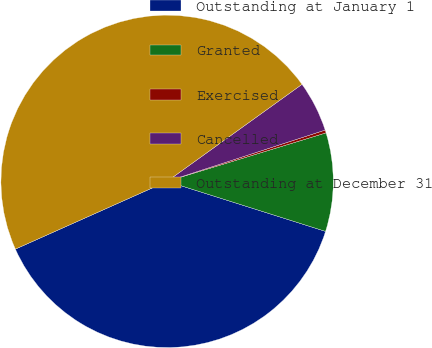Convert chart. <chart><loc_0><loc_0><loc_500><loc_500><pie_chart><fcel>Outstanding at January 1<fcel>Granted<fcel>Exercised<fcel>Cancelled<fcel>Outstanding at December 31<nl><fcel>38.44%<fcel>9.58%<fcel>0.28%<fcel>4.93%<fcel>46.76%<nl></chart> 